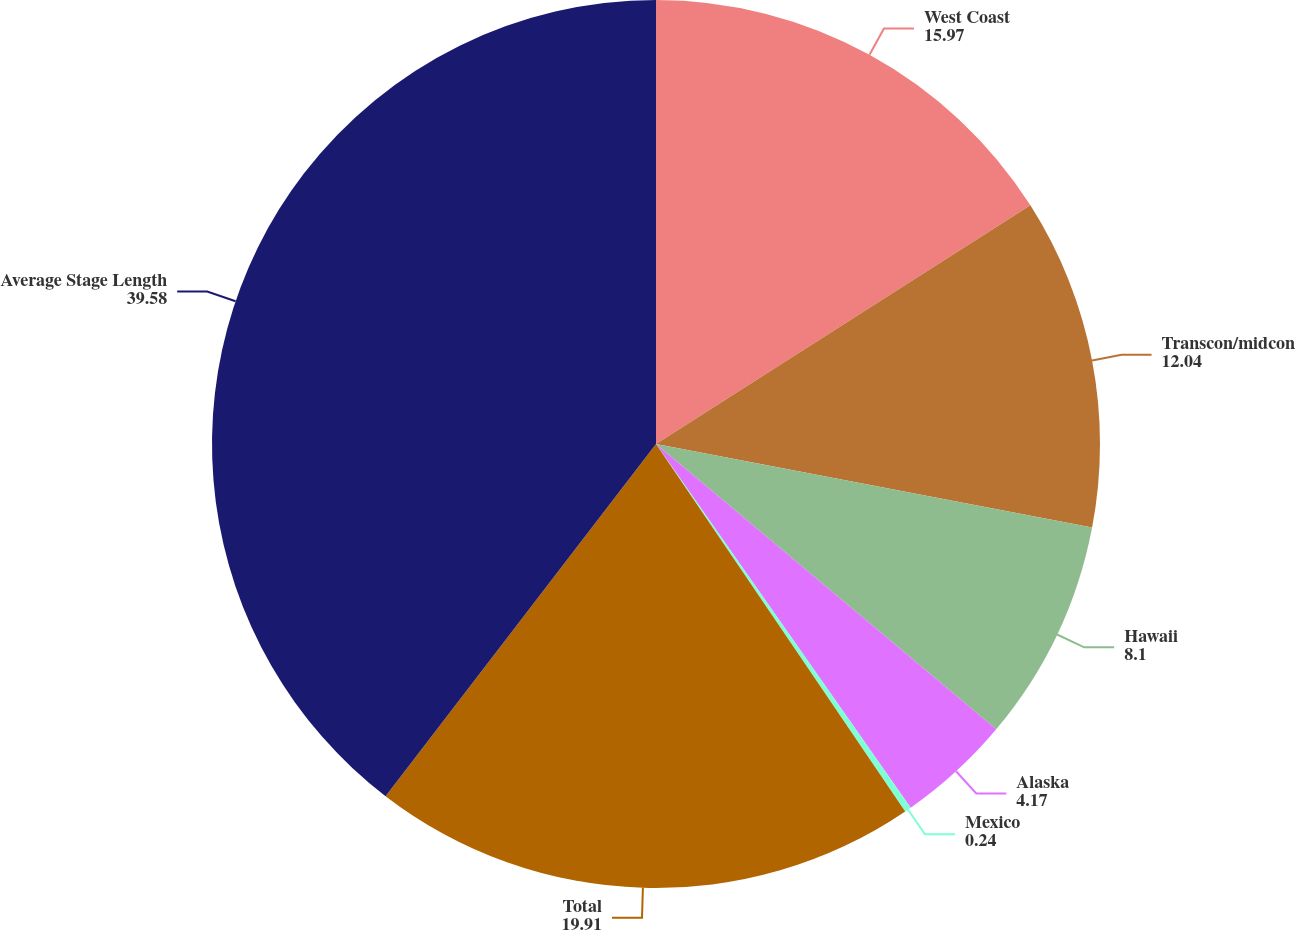Convert chart. <chart><loc_0><loc_0><loc_500><loc_500><pie_chart><fcel>West Coast<fcel>Transcon/midcon<fcel>Hawaii<fcel>Alaska<fcel>Mexico<fcel>Total<fcel>Average Stage Length<nl><fcel>15.97%<fcel>12.04%<fcel>8.1%<fcel>4.17%<fcel>0.24%<fcel>19.91%<fcel>39.58%<nl></chart> 